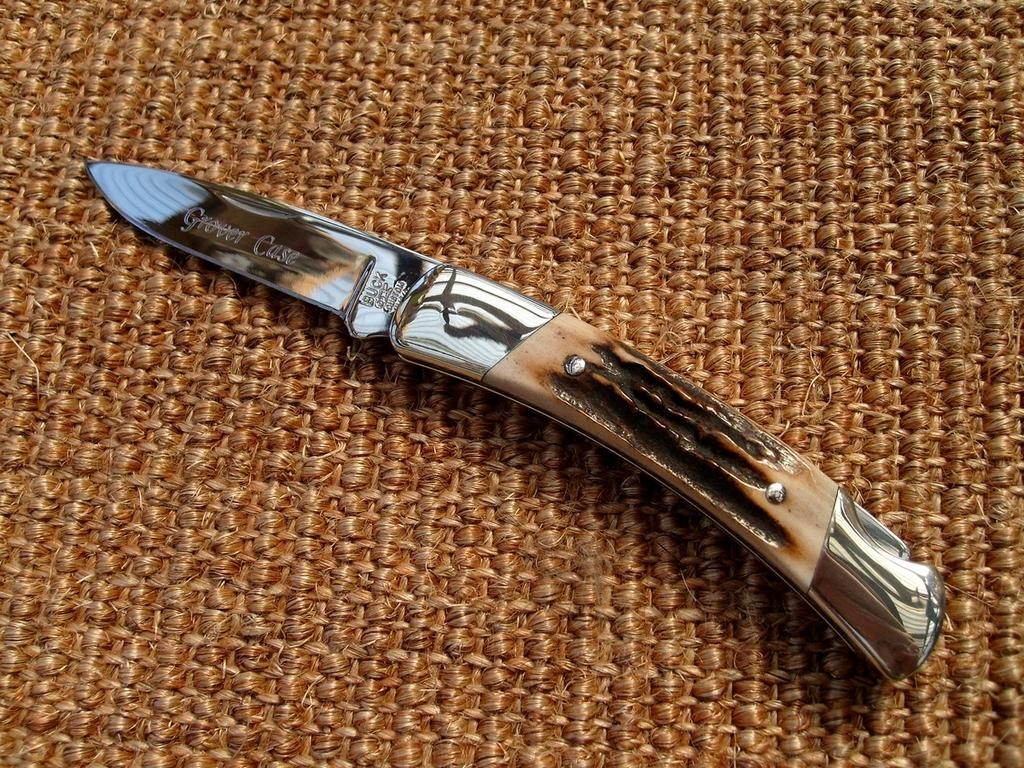What object is the knife placed on in the image? The knife is on an object in the image. What type of collar is visible on the person attending the meeting in the image? There is no person or meeting present in the image, and therefore no collar can be observed. 